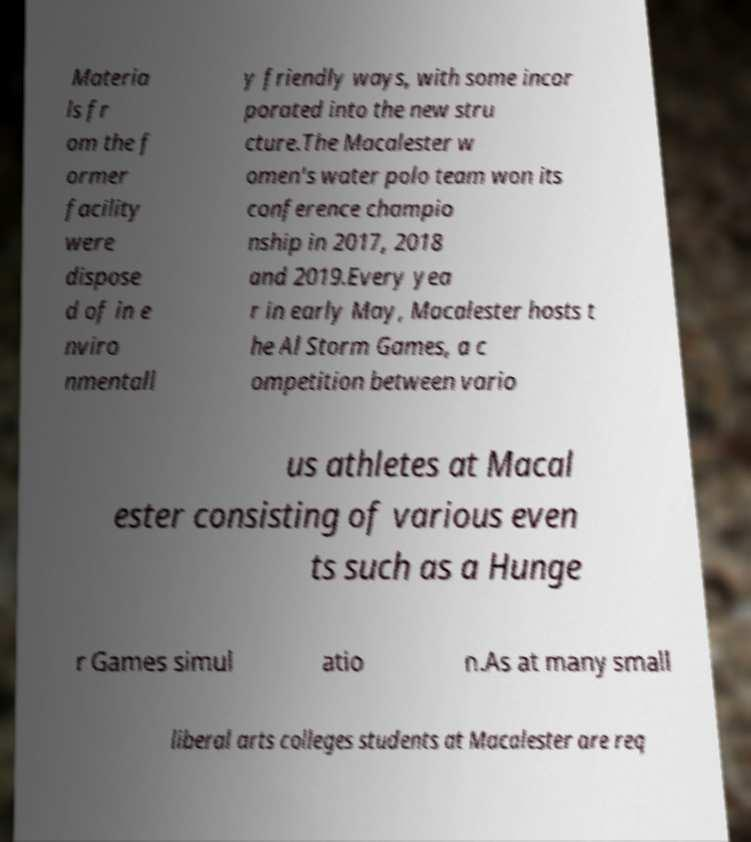For documentation purposes, I need the text within this image transcribed. Could you provide that? Materia ls fr om the f ormer facility were dispose d of in e nviro nmentall y friendly ways, with some incor porated into the new stru cture.The Macalester w omen's water polo team won its conference champio nship in 2017, 2018 and 2019.Every yea r in early May, Macalester hosts t he Al Storm Games, a c ompetition between vario us athletes at Macal ester consisting of various even ts such as a Hunge r Games simul atio n.As at many small liberal arts colleges students at Macalester are req 